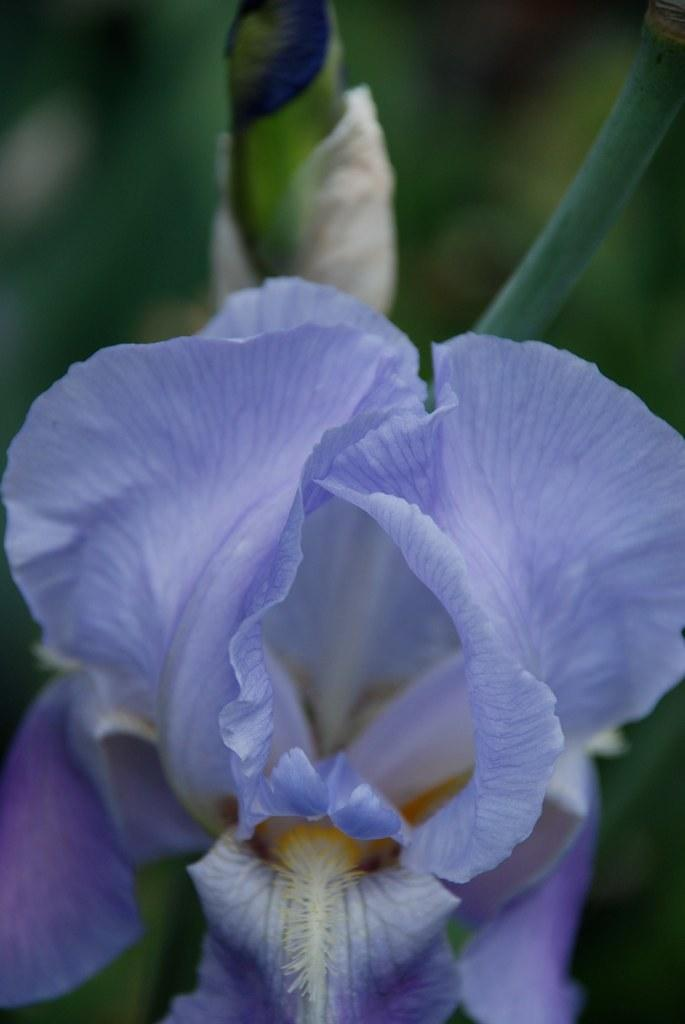What is the main subject of the image? There is a flower in the image. Can you describe the colors of the flower? The flower has purple, yellow, and white colors. How would you describe the background of the image? The background of the image is blurry. What color is the background? The background color is green. Can you tell me how many women are holding the flower in the image? There are no women present in the image; it features a flower with a blurry green background. What type of stem does the flower have in the image? The image does not show the stem of the flower, only the flower itself with its colors and the blurry green background. 